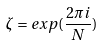<formula> <loc_0><loc_0><loc_500><loc_500>\zeta = e x p ( \frac { 2 \pi i } { N } )</formula> 